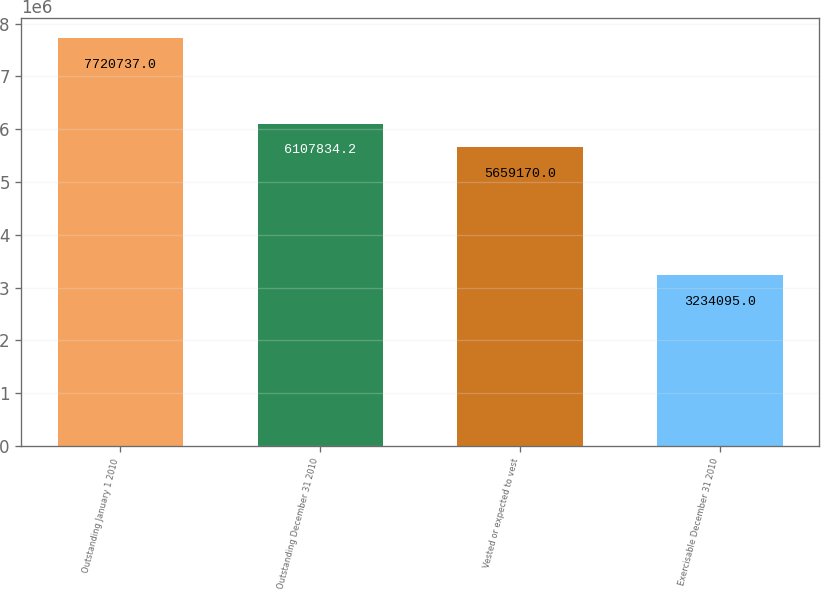Convert chart to OTSL. <chart><loc_0><loc_0><loc_500><loc_500><bar_chart><fcel>Outstanding January 1 2010<fcel>Outstanding December 31 2010<fcel>Vested or expected to vest<fcel>Exercisable December 31 2010<nl><fcel>7.72074e+06<fcel>6.10783e+06<fcel>5.65917e+06<fcel>3.2341e+06<nl></chart> 